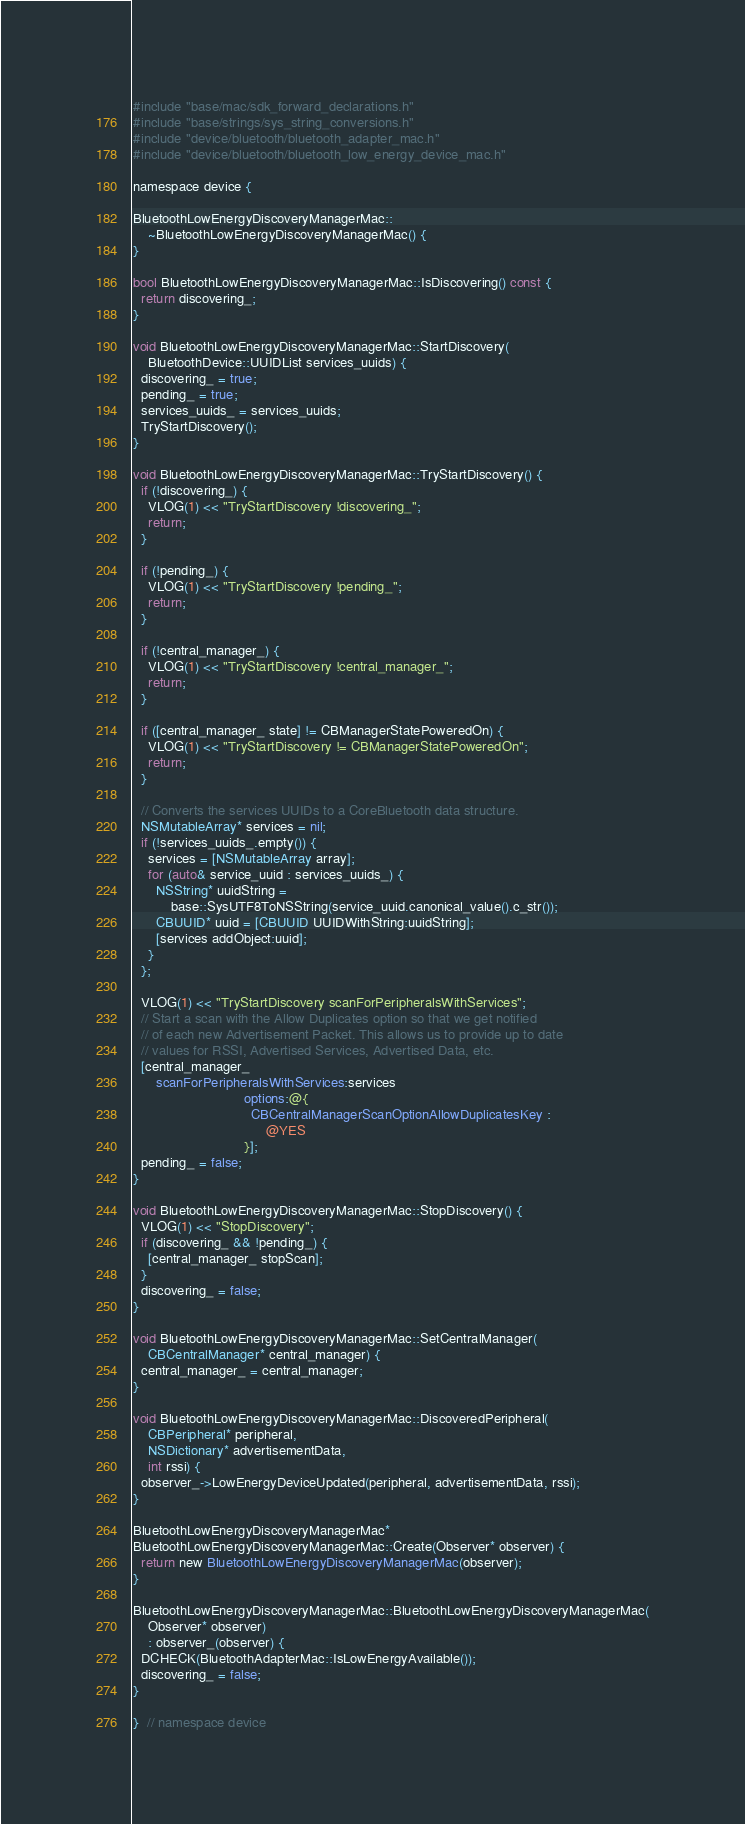Convert code to text. <code><loc_0><loc_0><loc_500><loc_500><_ObjectiveC_>#include "base/mac/sdk_forward_declarations.h"
#include "base/strings/sys_string_conversions.h"
#include "device/bluetooth/bluetooth_adapter_mac.h"
#include "device/bluetooth/bluetooth_low_energy_device_mac.h"

namespace device {

BluetoothLowEnergyDiscoveryManagerMac::
    ~BluetoothLowEnergyDiscoveryManagerMac() {
}

bool BluetoothLowEnergyDiscoveryManagerMac::IsDiscovering() const {
  return discovering_;
}

void BluetoothLowEnergyDiscoveryManagerMac::StartDiscovery(
    BluetoothDevice::UUIDList services_uuids) {
  discovering_ = true;
  pending_ = true;
  services_uuids_ = services_uuids;
  TryStartDiscovery();
}

void BluetoothLowEnergyDiscoveryManagerMac::TryStartDiscovery() {
  if (!discovering_) {
    VLOG(1) << "TryStartDiscovery !discovering_";
    return;
  }

  if (!pending_) {
    VLOG(1) << "TryStartDiscovery !pending_";
    return;
  }

  if (!central_manager_) {
    VLOG(1) << "TryStartDiscovery !central_manager_";
    return;
  }

  if ([central_manager_ state] != CBManagerStatePoweredOn) {
    VLOG(1) << "TryStartDiscovery != CBManagerStatePoweredOn";
    return;
  }

  // Converts the services UUIDs to a CoreBluetooth data structure.
  NSMutableArray* services = nil;
  if (!services_uuids_.empty()) {
    services = [NSMutableArray array];
    for (auto& service_uuid : services_uuids_) {
      NSString* uuidString =
          base::SysUTF8ToNSString(service_uuid.canonical_value().c_str());
      CBUUID* uuid = [CBUUID UUIDWithString:uuidString];
      [services addObject:uuid];
    }
  };

  VLOG(1) << "TryStartDiscovery scanForPeripheralsWithServices";
  // Start a scan with the Allow Duplicates option so that we get notified
  // of each new Advertisement Packet. This allows us to provide up to date
  // values for RSSI, Advertised Services, Advertised Data, etc.
  [central_manager_
      scanForPeripheralsWithServices:services
                             options:@{
                               CBCentralManagerScanOptionAllowDuplicatesKey :
                                   @YES
                             }];
  pending_ = false;
}

void BluetoothLowEnergyDiscoveryManagerMac::StopDiscovery() {
  VLOG(1) << "StopDiscovery";
  if (discovering_ && !pending_) {
    [central_manager_ stopScan];
  }
  discovering_ = false;
}

void BluetoothLowEnergyDiscoveryManagerMac::SetCentralManager(
    CBCentralManager* central_manager) {
  central_manager_ = central_manager;
}

void BluetoothLowEnergyDiscoveryManagerMac::DiscoveredPeripheral(
    CBPeripheral* peripheral,
    NSDictionary* advertisementData,
    int rssi) {
  observer_->LowEnergyDeviceUpdated(peripheral, advertisementData, rssi);
}

BluetoothLowEnergyDiscoveryManagerMac*
BluetoothLowEnergyDiscoveryManagerMac::Create(Observer* observer) {
  return new BluetoothLowEnergyDiscoveryManagerMac(observer);
}

BluetoothLowEnergyDiscoveryManagerMac::BluetoothLowEnergyDiscoveryManagerMac(
    Observer* observer)
    : observer_(observer) {
  DCHECK(BluetoothAdapterMac::IsLowEnergyAvailable());
  discovering_ = false;
}

}  // namespace device
</code> 